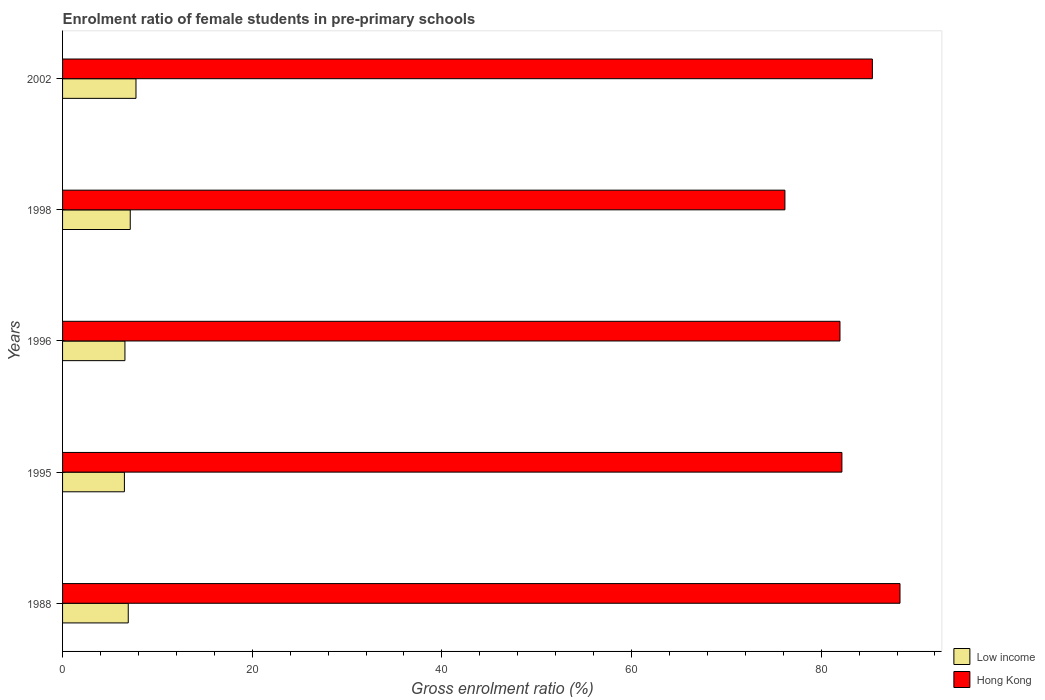How many groups of bars are there?
Your response must be concise. 5. Are the number of bars per tick equal to the number of legend labels?
Provide a succinct answer. Yes. Are the number of bars on each tick of the Y-axis equal?
Provide a succinct answer. Yes. How many bars are there on the 1st tick from the top?
Make the answer very short. 2. How many bars are there on the 2nd tick from the bottom?
Offer a very short reply. 2. What is the label of the 5th group of bars from the top?
Provide a succinct answer. 1988. What is the enrolment ratio of female students in pre-primary schools in Low income in 1988?
Make the answer very short. 6.93. Across all years, what is the maximum enrolment ratio of female students in pre-primary schools in Hong Kong?
Your answer should be compact. 88.31. Across all years, what is the minimum enrolment ratio of female students in pre-primary schools in Low income?
Offer a terse response. 6.52. In which year was the enrolment ratio of female students in pre-primary schools in Low income maximum?
Your answer should be very brief. 2002. In which year was the enrolment ratio of female students in pre-primary schools in Low income minimum?
Provide a short and direct response. 1995. What is the total enrolment ratio of female students in pre-primary schools in Low income in the graph?
Provide a short and direct response. 34.91. What is the difference between the enrolment ratio of female students in pre-primary schools in Low income in 1988 and that in 1996?
Make the answer very short. 0.35. What is the difference between the enrolment ratio of female students in pre-primary schools in Low income in 1988 and the enrolment ratio of female students in pre-primary schools in Hong Kong in 1998?
Keep it short and to the point. -69.25. What is the average enrolment ratio of female students in pre-primary schools in Hong Kong per year?
Offer a terse response. 82.81. In the year 1995, what is the difference between the enrolment ratio of female students in pre-primary schools in Low income and enrolment ratio of female students in pre-primary schools in Hong Kong?
Your response must be concise. -75.66. What is the ratio of the enrolment ratio of female students in pre-primary schools in Low income in 1996 to that in 2002?
Your answer should be compact. 0.85. Is the enrolment ratio of female students in pre-primary schools in Hong Kong in 1988 less than that in 1998?
Provide a short and direct response. No. What is the difference between the highest and the second highest enrolment ratio of female students in pre-primary schools in Low income?
Give a very brief answer. 0.61. What is the difference between the highest and the lowest enrolment ratio of female students in pre-primary schools in Low income?
Give a very brief answer. 1.22. In how many years, is the enrolment ratio of female students in pre-primary schools in Low income greater than the average enrolment ratio of female students in pre-primary schools in Low income taken over all years?
Offer a very short reply. 2. Is the sum of the enrolment ratio of female students in pre-primary schools in Low income in 1988 and 1996 greater than the maximum enrolment ratio of female students in pre-primary schools in Hong Kong across all years?
Provide a short and direct response. No. What does the 1st bar from the top in 1988 represents?
Make the answer very short. Hong Kong. What does the 2nd bar from the bottom in 1996 represents?
Provide a succinct answer. Hong Kong. How many bars are there?
Offer a very short reply. 10. Are all the bars in the graph horizontal?
Provide a succinct answer. Yes. What is the difference between two consecutive major ticks on the X-axis?
Offer a terse response. 20. Does the graph contain grids?
Your response must be concise. No. How are the legend labels stacked?
Give a very brief answer. Vertical. What is the title of the graph?
Ensure brevity in your answer.  Enrolment ratio of female students in pre-primary schools. What is the Gross enrolment ratio (%) in Low income in 1988?
Your answer should be compact. 6.93. What is the Gross enrolment ratio (%) of Hong Kong in 1988?
Your answer should be very brief. 88.31. What is the Gross enrolment ratio (%) of Low income in 1995?
Give a very brief answer. 6.52. What is the Gross enrolment ratio (%) in Hong Kong in 1995?
Make the answer very short. 82.19. What is the Gross enrolment ratio (%) of Low income in 1996?
Offer a very short reply. 6.58. What is the Gross enrolment ratio (%) of Hong Kong in 1996?
Offer a very short reply. 81.98. What is the Gross enrolment ratio (%) of Low income in 1998?
Give a very brief answer. 7.14. What is the Gross enrolment ratio (%) of Hong Kong in 1998?
Keep it short and to the point. 76.18. What is the Gross enrolment ratio (%) in Low income in 2002?
Your answer should be compact. 7.74. What is the Gross enrolment ratio (%) of Hong Kong in 2002?
Keep it short and to the point. 85.4. Across all years, what is the maximum Gross enrolment ratio (%) of Low income?
Make the answer very short. 7.74. Across all years, what is the maximum Gross enrolment ratio (%) in Hong Kong?
Your answer should be compact. 88.31. Across all years, what is the minimum Gross enrolment ratio (%) in Low income?
Ensure brevity in your answer.  6.52. Across all years, what is the minimum Gross enrolment ratio (%) of Hong Kong?
Provide a short and direct response. 76.18. What is the total Gross enrolment ratio (%) in Low income in the graph?
Offer a terse response. 34.91. What is the total Gross enrolment ratio (%) in Hong Kong in the graph?
Keep it short and to the point. 414.06. What is the difference between the Gross enrolment ratio (%) of Low income in 1988 and that in 1995?
Provide a succinct answer. 0.41. What is the difference between the Gross enrolment ratio (%) of Hong Kong in 1988 and that in 1995?
Your answer should be compact. 6.13. What is the difference between the Gross enrolment ratio (%) in Low income in 1988 and that in 1996?
Your answer should be compact. 0.35. What is the difference between the Gross enrolment ratio (%) of Hong Kong in 1988 and that in 1996?
Ensure brevity in your answer.  6.33. What is the difference between the Gross enrolment ratio (%) in Low income in 1988 and that in 1998?
Your response must be concise. -0.21. What is the difference between the Gross enrolment ratio (%) of Hong Kong in 1988 and that in 1998?
Provide a short and direct response. 12.14. What is the difference between the Gross enrolment ratio (%) of Low income in 1988 and that in 2002?
Keep it short and to the point. -0.82. What is the difference between the Gross enrolment ratio (%) in Hong Kong in 1988 and that in 2002?
Give a very brief answer. 2.91. What is the difference between the Gross enrolment ratio (%) of Low income in 1995 and that in 1996?
Your answer should be compact. -0.05. What is the difference between the Gross enrolment ratio (%) in Hong Kong in 1995 and that in 1996?
Keep it short and to the point. 0.2. What is the difference between the Gross enrolment ratio (%) in Low income in 1995 and that in 1998?
Your response must be concise. -0.61. What is the difference between the Gross enrolment ratio (%) of Hong Kong in 1995 and that in 1998?
Offer a very short reply. 6.01. What is the difference between the Gross enrolment ratio (%) in Low income in 1995 and that in 2002?
Offer a very short reply. -1.22. What is the difference between the Gross enrolment ratio (%) of Hong Kong in 1995 and that in 2002?
Give a very brief answer. -3.21. What is the difference between the Gross enrolment ratio (%) in Low income in 1996 and that in 1998?
Make the answer very short. -0.56. What is the difference between the Gross enrolment ratio (%) in Hong Kong in 1996 and that in 1998?
Your response must be concise. 5.81. What is the difference between the Gross enrolment ratio (%) in Low income in 1996 and that in 2002?
Your answer should be compact. -1.17. What is the difference between the Gross enrolment ratio (%) in Hong Kong in 1996 and that in 2002?
Keep it short and to the point. -3.42. What is the difference between the Gross enrolment ratio (%) in Low income in 1998 and that in 2002?
Your answer should be very brief. -0.61. What is the difference between the Gross enrolment ratio (%) of Hong Kong in 1998 and that in 2002?
Keep it short and to the point. -9.22. What is the difference between the Gross enrolment ratio (%) in Low income in 1988 and the Gross enrolment ratio (%) in Hong Kong in 1995?
Provide a succinct answer. -75.26. What is the difference between the Gross enrolment ratio (%) of Low income in 1988 and the Gross enrolment ratio (%) of Hong Kong in 1996?
Keep it short and to the point. -75.06. What is the difference between the Gross enrolment ratio (%) of Low income in 1988 and the Gross enrolment ratio (%) of Hong Kong in 1998?
Make the answer very short. -69.25. What is the difference between the Gross enrolment ratio (%) in Low income in 1988 and the Gross enrolment ratio (%) in Hong Kong in 2002?
Keep it short and to the point. -78.47. What is the difference between the Gross enrolment ratio (%) of Low income in 1995 and the Gross enrolment ratio (%) of Hong Kong in 1996?
Keep it short and to the point. -75.46. What is the difference between the Gross enrolment ratio (%) of Low income in 1995 and the Gross enrolment ratio (%) of Hong Kong in 1998?
Your response must be concise. -69.66. What is the difference between the Gross enrolment ratio (%) of Low income in 1995 and the Gross enrolment ratio (%) of Hong Kong in 2002?
Ensure brevity in your answer.  -78.88. What is the difference between the Gross enrolment ratio (%) of Low income in 1996 and the Gross enrolment ratio (%) of Hong Kong in 1998?
Your answer should be compact. -69.6. What is the difference between the Gross enrolment ratio (%) in Low income in 1996 and the Gross enrolment ratio (%) in Hong Kong in 2002?
Your answer should be compact. -78.82. What is the difference between the Gross enrolment ratio (%) of Low income in 1998 and the Gross enrolment ratio (%) of Hong Kong in 2002?
Your answer should be very brief. -78.26. What is the average Gross enrolment ratio (%) in Low income per year?
Keep it short and to the point. 6.98. What is the average Gross enrolment ratio (%) of Hong Kong per year?
Your answer should be compact. 82.81. In the year 1988, what is the difference between the Gross enrolment ratio (%) of Low income and Gross enrolment ratio (%) of Hong Kong?
Offer a very short reply. -81.39. In the year 1995, what is the difference between the Gross enrolment ratio (%) of Low income and Gross enrolment ratio (%) of Hong Kong?
Ensure brevity in your answer.  -75.66. In the year 1996, what is the difference between the Gross enrolment ratio (%) in Low income and Gross enrolment ratio (%) in Hong Kong?
Offer a terse response. -75.41. In the year 1998, what is the difference between the Gross enrolment ratio (%) of Low income and Gross enrolment ratio (%) of Hong Kong?
Offer a very short reply. -69.04. In the year 2002, what is the difference between the Gross enrolment ratio (%) in Low income and Gross enrolment ratio (%) in Hong Kong?
Your answer should be very brief. -77.66. What is the ratio of the Gross enrolment ratio (%) of Low income in 1988 to that in 1995?
Your answer should be compact. 1.06. What is the ratio of the Gross enrolment ratio (%) in Hong Kong in 1988 to that in 1995?
Ensure brevity in your answer.  1.07. What is the ratio of the Gross enrolment ratio (%) in Low income in 1988 to that in 1996?
Your answer should be compact. 1.05. What is the ratio of the Gross enrolment ratio (%) in Hong Kong in 1988 to that in 1996?
Make the answer very short. 1.08. What is the ratio of the Gross enrolment ratio (%) in Low income in 1988 to that in 1998?
Ensure brevity in your answer.  0.97. What is the ratio of the Gross enrolment ratio (%) of Hong Kong in 1988 to that in 1998?
Your answer should be compact. 1.16. What is the ratio of the Gross enrolment ratio (%) of Low income in 1988 to that in 2002?
Provide a short and direct response. 0.89. What is the ratio of the Gross enrolment ratio (%) in Hong Kong in 1988 to that in 2002?
Ensure brevity in your answer.  1.03. What is the ratio of the Gross enrolment ratio (%) in Low income in 1995 to that in 1996?
Keep it short and to the point. 0.99. What is the ratio of the Gross enrolment ratio (%) of Low income in 1995 to that in 1998?
Offer a terse response. 0.91. What is the ratio of the Gross enrolment ratio (%) in Hong Kong in 1995 to that in 1998?
Ensure brevity in your answer.  1.08. What is the ratio of the Gross enrolment ratio (%) of Low income in 1995 to that in 2002?
Your response must be concise. 0.84. What is the ratio of the Gross enrolment ratio (%) of Hong Kong in 1995 to that in 2002?
Your answer should be compact. 0.96. What is the ratio of the Gross enrolment ratio (%) in Low income in 1996 to that in 1998?
Give a very brief answer. 0.92. What is the ratio of the Gross enrolment ratio (%) of Hong Kong in 1996 to that in 1998?
Your answer should be compact. 1.08. What is the ratio of the Gross enrolment ratio (%) in Low income in 1996 to that in 2002?
Make the answer very short. 0.85. What is the ratio of the Gross enrolment ratio (%) of Hong Kong in 1996 to that in 2002?
Your answer should be compact. 0.96. What is the ratio of the Gross enrolment ratio (%) in Low income in 1998 to that in 2002?
Provide a succinct answer. 0.92. What is the ratio of the Gross enrolment ratio (%) in Hong Kong in 1998 to that in 2002?
Offer a terse response. 0.89. What is the difference between the highest and the second highest Gross enrolment ratio (%) in Low income?
Provide a short and direct response. 0.61. What is the difference between the highest and the second highest Gross enrolment ratio (%) of Hong Kong?
Provide a short and direct response. 2.91. What is the difference between the highest and the lowest Gross enrolment ratio (%) in Low income?
Offer a terse response. 1.22. What is the difference between the highest and the lowest Gross enrolment ratio (%) of Hong Kong?
Your answer should be very brief. 12.14. 